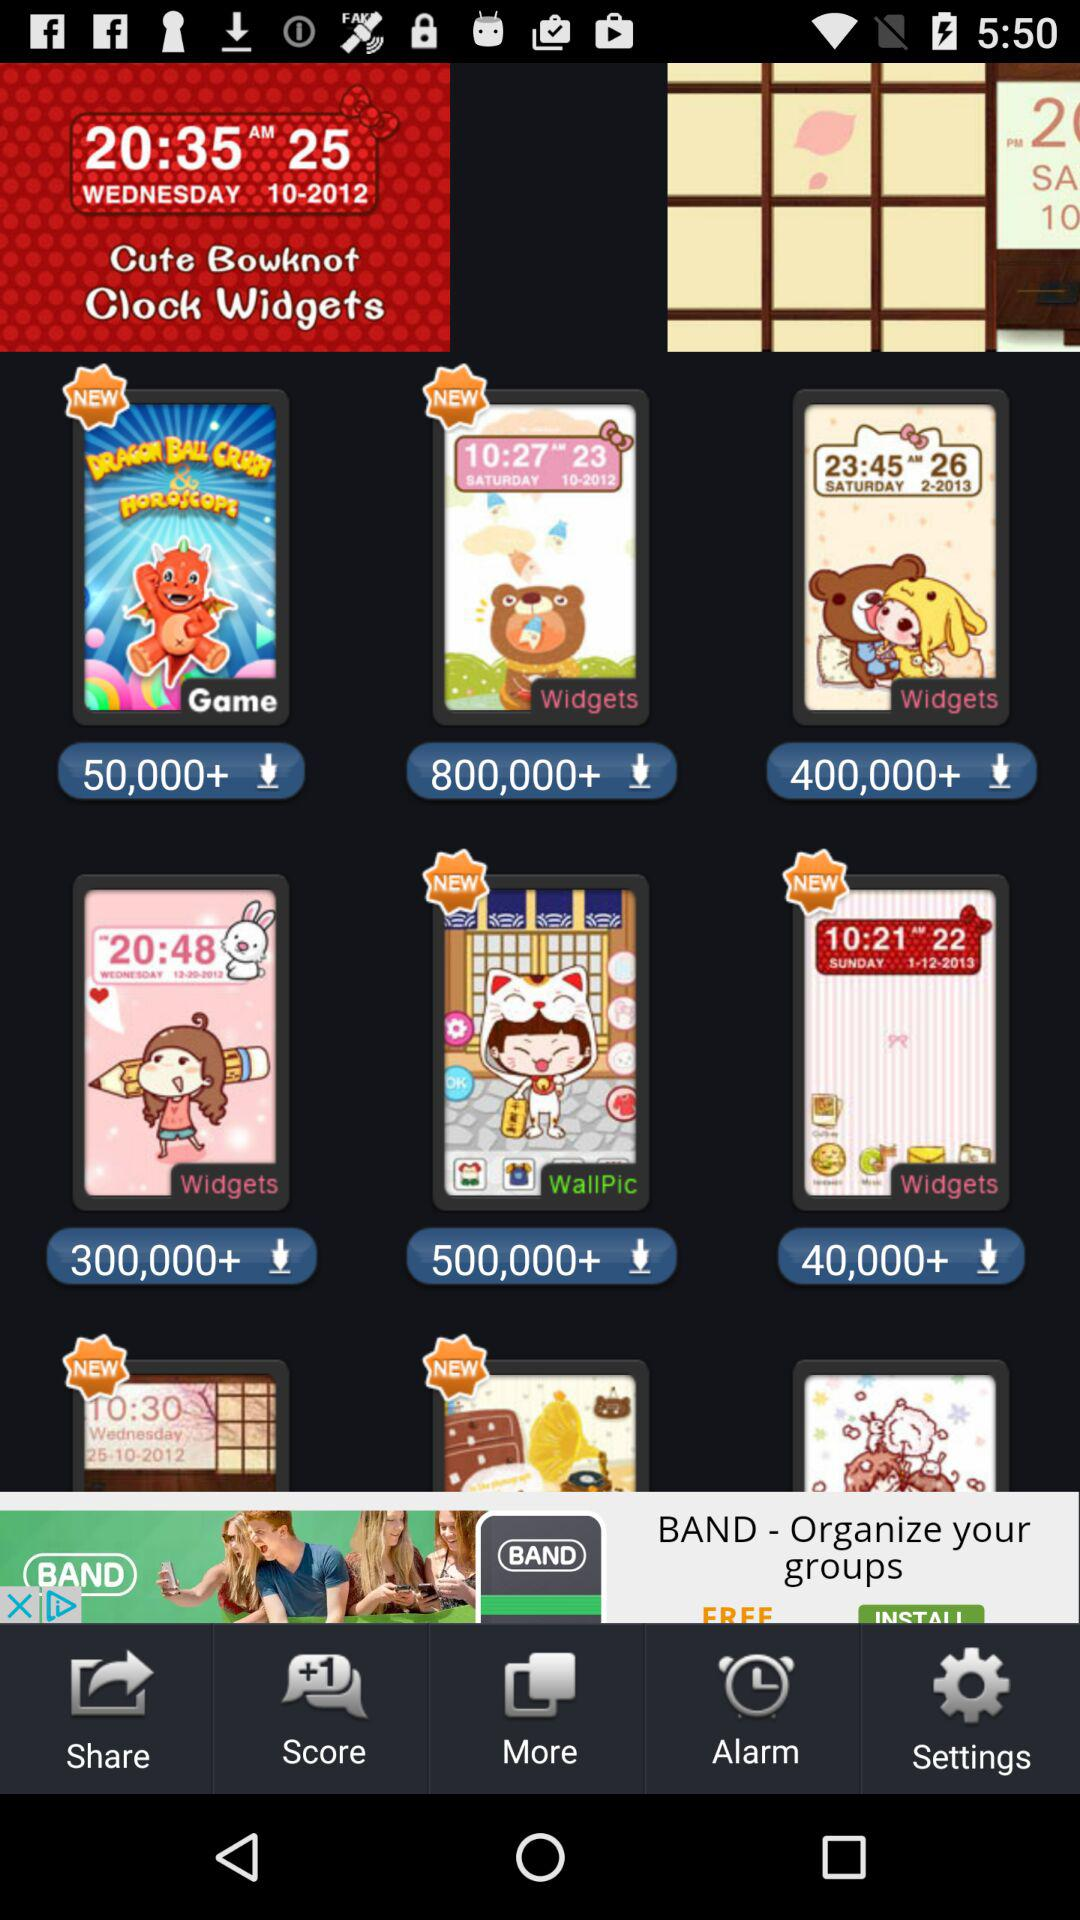What is the total number of downloads of "WallPic"? The total number of downloads of "WallPic" is more than 500,000. 